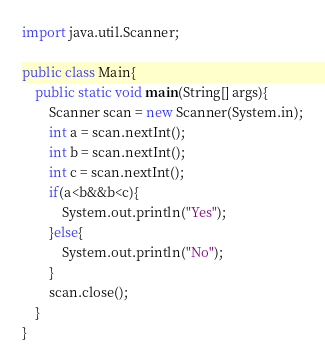<code> <loc_0><loc_0><loc_500><loc_500><_Java_>import java.util.Scanner;

public class Main{
    public static void main(String[] args){
        Scanner scan = new Scanner(System.in);
        int a = scan.nextInt();
        int b = scan.nextInt();
        int c = scan.nextInt();
        if(a<b&&b<c){
            System.out.println("Yes");
        }else{
            System.out.println("No");
        }
        scan.close();
    }
}
</code> 